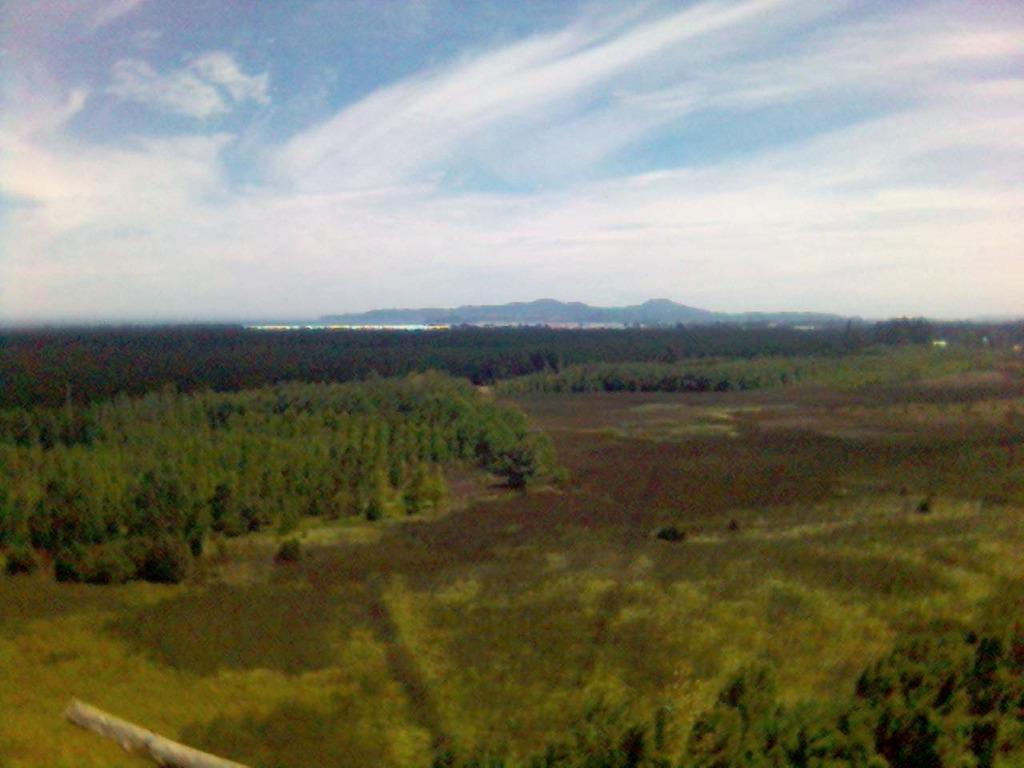What type of landscape is shown in the image? The image depicts an open land. What type of vegetation can be seen in the image? There is grass and trees visible in the image. What geographical features are present in the image? There are mountains and water visible in the image. What is visible in the sky in the image? There are clouds in the sky in the image. What type of punishment is being handed out to the cracker in the image? There is no cracker or punishment present in the image. 